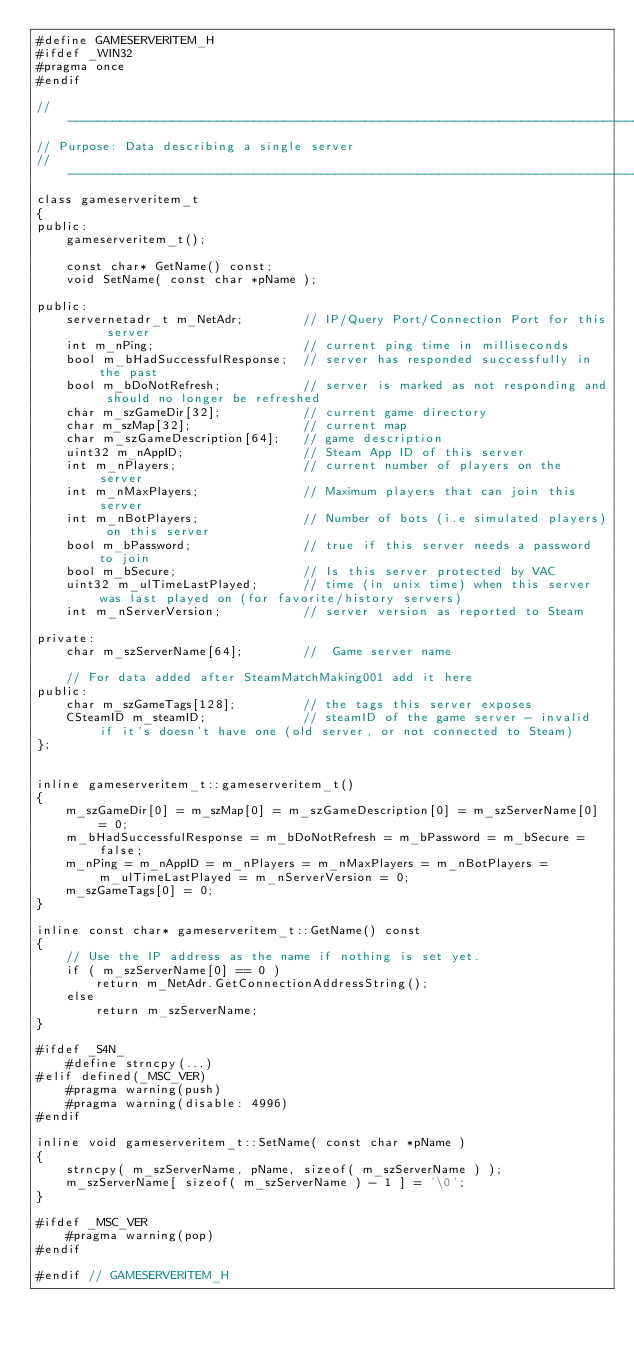Convert code to text. <code><loc_0><loc_0><loc_500><loc_500><_C_>#define GAMESERVERITEM_H
#ifdef _WIN32
#pragma once
#endif

//-----------------------------------------------------------------------------
// Purpose: Data describing a single server
//-----------------------------------------------------------------------------
class gameserveritem_t
{
public:
	gameserveritem_t();

	const char* GetName() const;
	void SetName( const char *pName );

public:
	servernetadr_t m_NetAdr;		// IP/Query Port/Connection Port for this server
	int m_nPing;					// current ping time in milliseconds
	bool m_bHadSuccessfulResponse;	// server has responded successfully in the past
	bool m_bDoNotRefresh;			// server is marked as not responding and should no longer be refreshed
	char m_szGameDir[32];			// current game directory
	char m_szMap[32];				// current map
	char m_szGameDescription[64];	// game description
	uint32 m_nAppID;				// Steam App ID of this server
	int m_nPlayers;					// current number of players on the server
	int m_nMaxPlayers;				// Maximum players that can join this server
	int m_nBotPlayers;				// Number of bots (i.e simulated players) on this server
	bool m_bPassword;				// true if this server needs a password to join
	bool m_bSecure;					// Is this server protected by VAC
	uint32 m_ulTimeLastPlayed;		// time (in unix time) when this server was last played on (for favorite/history servers)
	int	m_nServerVersion;			// server version as reported to Steam

private:
	char m_szServerName[64];		//  Game server name

	// For data added after SteamMatchMaking001 add it here
public:
	char m_szGameTags[128];			// the tags this server exposes
	CSteamID m_steamID;				// steamID of the game server - invalid if it's doesn't have one (old server, or not connected to Steam)
};


inline gameserveritem_t::gameserveritem_t()
{
	m_szGameDir[0] = m_szMap[0] = m_szGameDescription[0] = m_szServerName[0] = 0;
	m_bHadSuccessfulResponse = m_bDoNotRefresh = m_bPassword = m_bSecure = false;
	m_nPing = m_nAppID = m_nPlayers = m_nMaxPlayers = m_nBotPlayers = m_ulTimeLastPlayed = m_nServerVersion = 0;
	m_szGameTags[0] = 0;
}

inline const char* gameserveritem_t::GetName() const
{
	// Use the IP address as the name if nothing is set yet.
	if ( m_szServerName[0] == 0 )
		return m_NetAdr.GetConnectionAddressString();
	else
		return m_szServerName;
}

#ifdef _S4N_
	#define strncpy(...)
#elif defined(_MSC_VER)
	#pragma warning(push) 
	#pragma warning(disable: 4996) 
#endif

inline void gameserveritem_t::SetName( const char *pName )
{
	strncpy( m_szServerName, pName, sizeof( m_szServerName ) );
	m_szServerName[ sizeof( m_szServerName ) - 1 ] = '\0';
}

#ifdef _MSC_VER
	#pragma warning(pop) 
#endif

#endif // GAMESERVERITEM_H
</code> 